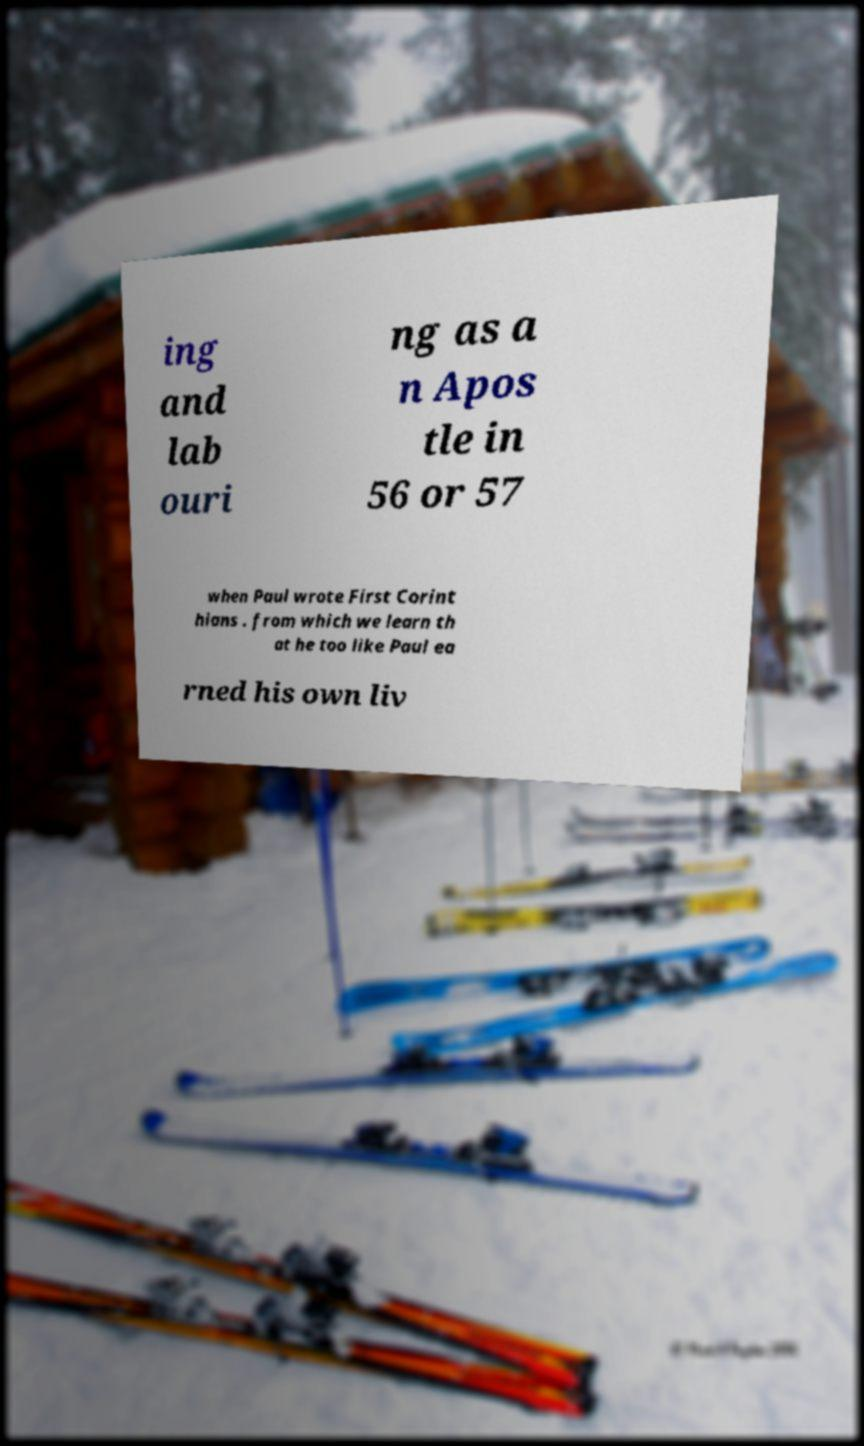I need the written content from this picture converted into text. Can you do that? ing and lab ouri ng as a n Apos tle in 56 or 57 when Paul wrote First Corint hians . from which we learn th at he too like Paul ea rned his own liv 